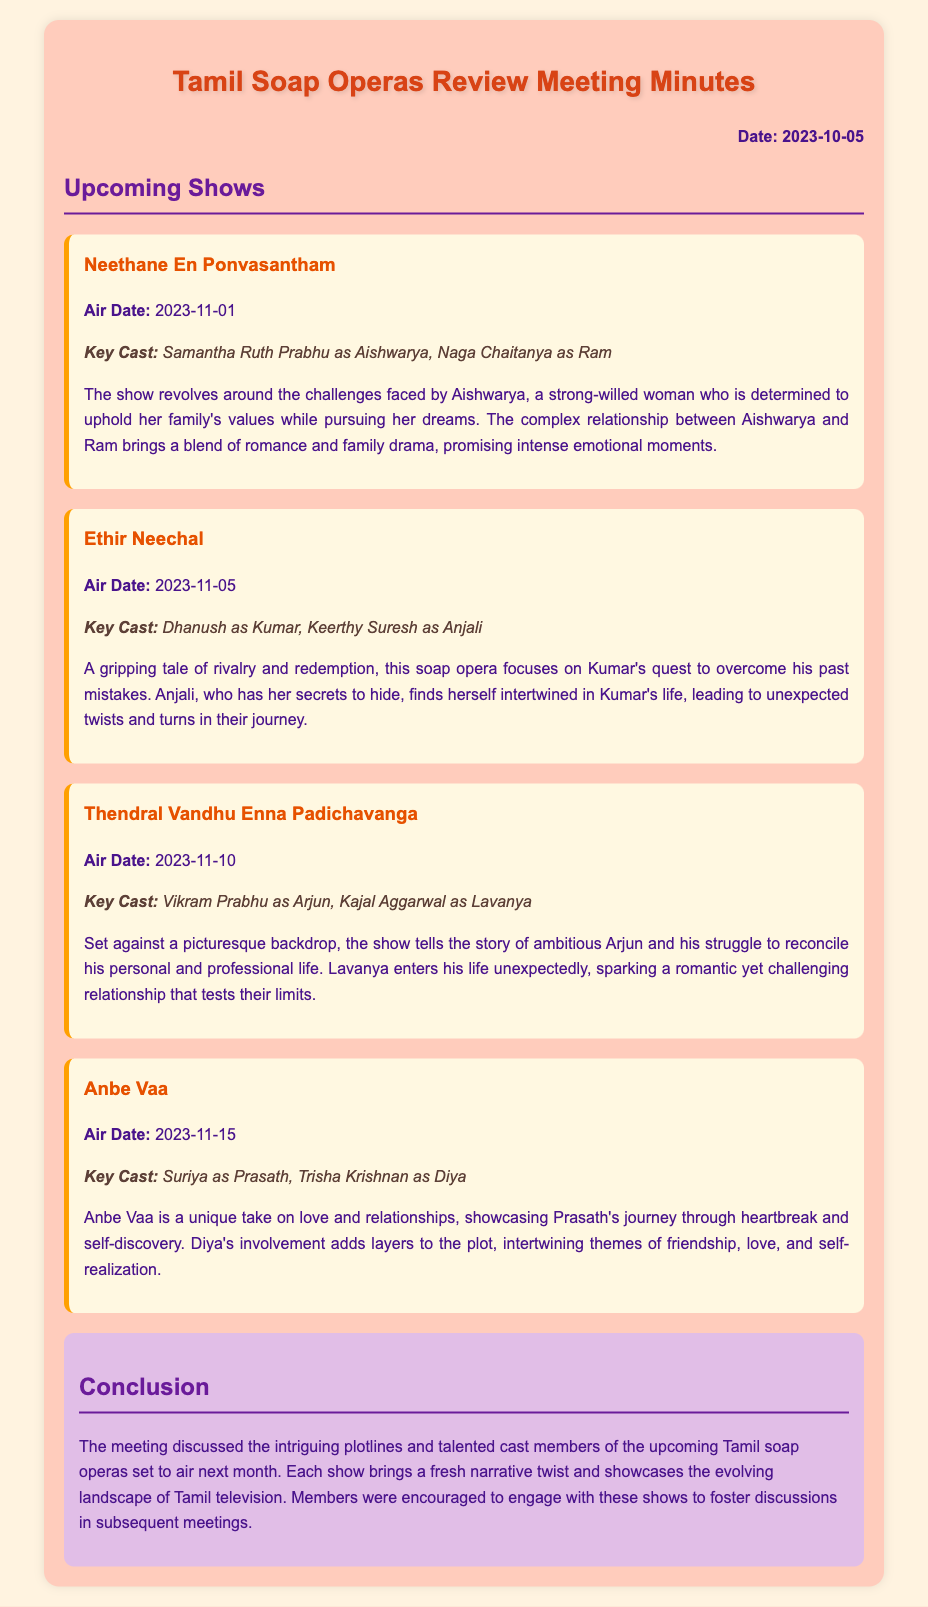what is the air date of Neethane En Ponvasantham? The document states that Neethane En Ponvasantham is scheduled to air on November 1, 2023.
Answer: November 1, 2023 who plays the role of Aishwarya? The minutes mention that Samantha Ruth Prabhu plays the role of Aishwarya in Neethane En Ponvasantham.
Answer: Samantha Ruth Prabhu what is the main theme of Thendral Vandhu Enna Padichavanga? The storyline discusses Arjun's struggle to reconcile his personal and professional life.
Answer: Personal and professional struggle which soap opera features Dhanush and Keerthy Suresh? The meeting minutes indicate that Ethir Neechal features Dhanush and Keerthy Suresh.
Answer: Ethir Neechal what are the key elements of Anbe Vaa's storyline? The document notes that Anbe Vaa showcases Prasath's journey through heartbreak and self-discovery.
Answer: Heartbreak and self-discovery how many soap operas are reviewed in the meeting? The document lists four upcoming soap operas that are reviewed.
Answer: Four what is the main conflict in Ethir Neechal? The storyline indicates that the main conflict revolves around rivalry and redemption.
Answer: Rivalry and redemption who is mentioned as playing the character of Diya? The minutes specify that Trisha Krishnan plays the character of Diya in Anbe Vaa.
Answer: Trisha Krishnan 